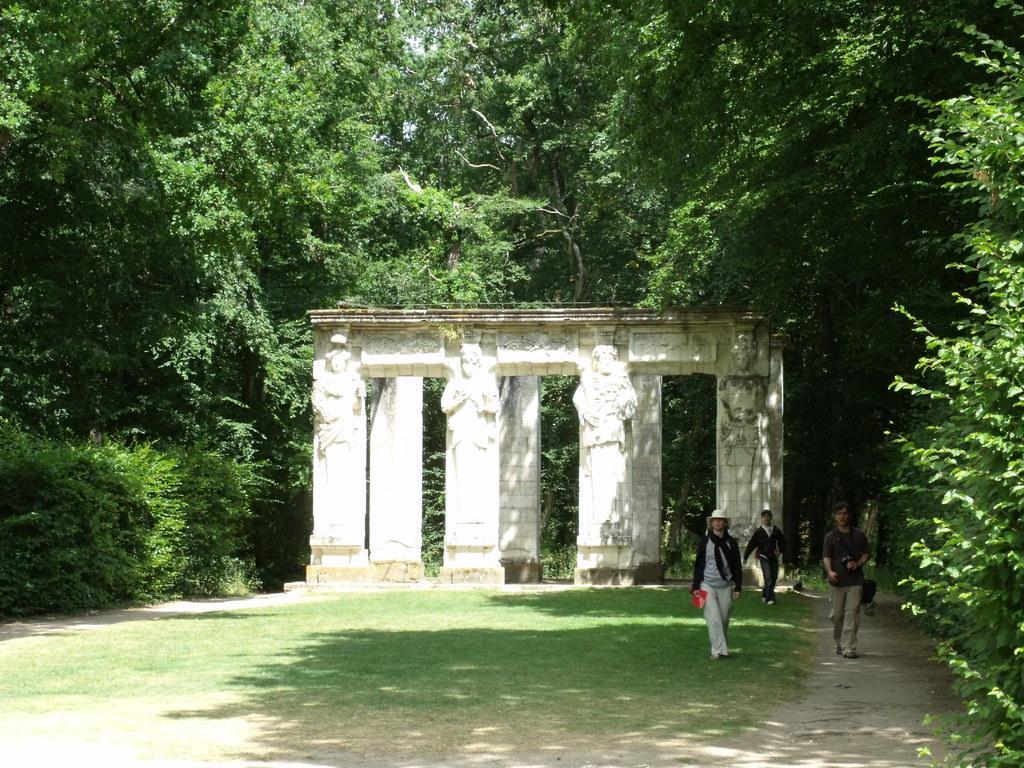Please provide a concise description of this image. In this image I see few sculptures and I see the pillars and these all are of white in color and I see 3 persons over here and I see the green grass and the path. In the background I see the trees. 